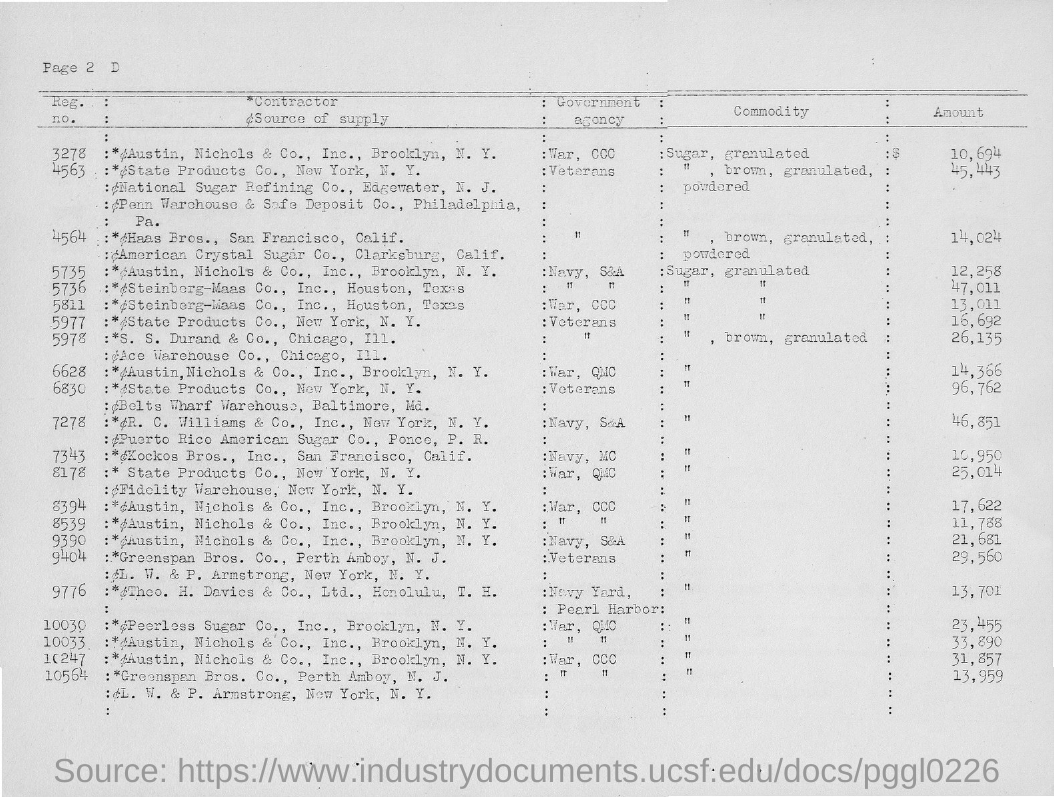What is the amount of the commodity with registration number 3278?
Your answer should be very brief. 10,694. What is the amount of the commodity with registration number 10564?
Provide a short and direct response. 13,959. What is the amount of the commodity with registration number 10247?
Ensure brevity in your answer.  31,857. What is the amount of the commodity with registration number 10033?
Your answer should be very brief. 33,890. 